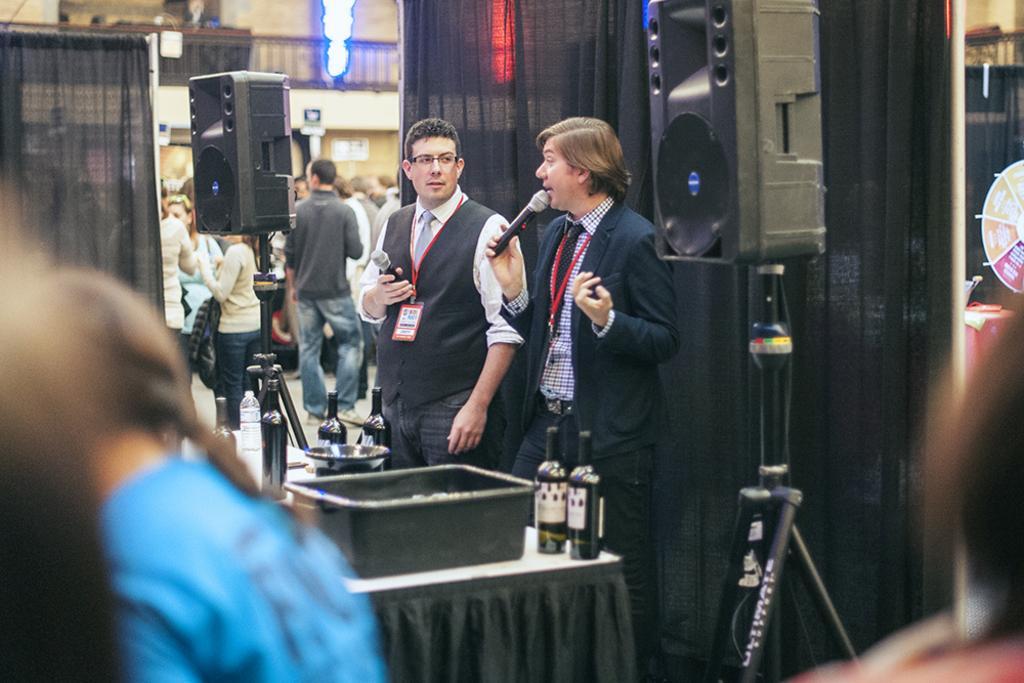Describe this image in one or two sentences. On the left there is a person. In the background there are two men holding mike in their hand. On the table there are wine bottles and a tub and we can also see speakers,curtains,few people over here,wall and lights. 